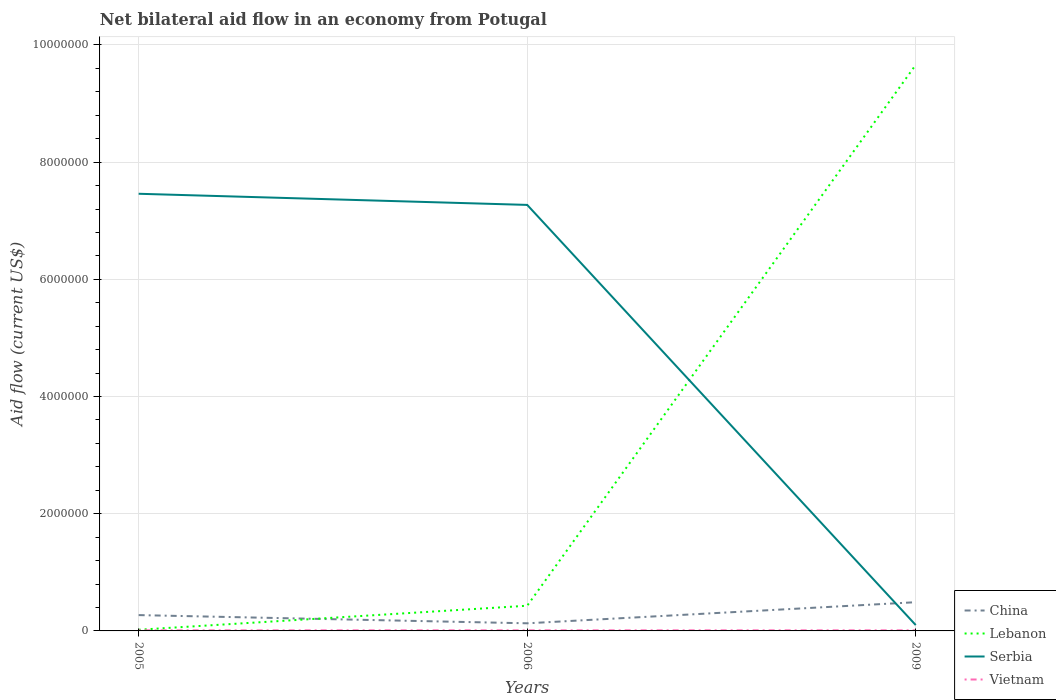How many different coloured lines are there?
Your answer should be very brief. 4. Does the line corresponding to Lebanon intersect with the line corresponding to Vietnam?
Make the answer very short. No. Is the number of lines equal to the number of legend labels?
Provide a succinct answer. Yes. In which year was the net bilateral aid flow in Serbia maximum?
Ensure brevity in your answer.  2009. What is the total net bilateral aid flow in Lebanon in the graph?
Keep it short and to the point. -9.64e+06. What is the difference between the highest and the second highest net bilateral aid flow in Serbia?
Provide a short and direct response. 7.36e+06. How many lines are there?
Your response must be concise. 4. What is the difference between two consecutive major ticks on the Y-axis?
Offer a terse response. 2.00e+06. Does the graph contain any zero values?
Give a very brief answer. No. How are the legend labels stacked?
Offer a very short reply. Vertical. What is the title of the graph?
Give a very brief answer. Net bilateral aid flow in an economy from Potugal. What is the label or title of the Y-axis?
Give a very brief answer. Aid flow (current US$). What is the Aid flow (current US$) of China in 2005?
Make the answer very short. 2.70e+05. What is the Aid flow (current US$) of Serbia in 2005?
Your answer should be very brief. 7.46e+06. What is the Aid flow (current US$) of China in 2006?
Your answer should be compact. 1.30e+05. What is the Aid flow (current US$) in Serbia in 2006?
Provide a short and direct response. 7.27e+06. What is the Aid flow (current US$) in Vietnam in 2006?
Provide a short and direct response. 10000. What is the Aid flow (current US$) in China in 2009?
Your answer should be compact. 4.90e+05. What is the Aid flow (current US$) of Lebanon in 2009?
Offer a terse response. 9.66e+06. What is the Aid flow (current US$) of Serbia in 2009?
Your response must be concise. 1.00e+05. Across all years, what is the maximum Aid flow (current US$) in Lebanon?
Give a very brief answer. 9.66e+06. Across all years, what is the maximum Aid flow (current US$) in Serbia?
Offer a terse response. 7.46e+06. Across all years, what is the minimum Aid flow (current US$) in China?
Make the answer very short. 1.30e+05. Across all years, what is the minimum Aid flow (current US$) in Lebanon?
Your answer should be very brief. 2.00e+04. Across all years, what is the minimum Aid flow (current US$) of Vietnam?
Give a very brief answer. 10000. What is the total Aid flow (current US$) of China in the graph?
Offer a terse response. 8.90e+05. What is the total Aid flow (current US$) of Lebanon in the graph?
Make the answer very short. 1.01e+07. What is the total Aid flow (current US$) in Serbia in the graph?
Offer a very short reply. 1.48e+07. What is the difference between the Aid flow (current US$) in Lebanon in 2005 and that in 2006?
Your answer should be very brief. -4.10e+05. What is the difference between the Aid flow (current US$) of China in 2005 and that in 2009?
Provide a succinct answer. -2.20e+05. What is the difference between the Aid flow (current US$) of Lebanon in 2005 and that in 2009?
Provide a succinct answer. -9.64e+06. What is the difference between the Aid flow (current US$) of Serbia in 2005 and that in 2009?
Make the answer very short. 7.36e+06. What is the difference between the Aid flow (current US$) of Vietnam in 2005 and that in 2009?
Give a very brief answer. 0. What is the difference between the Aid flow (current US$) in China in 2006 and that in 2009?
Provide a short and direct response. -3.60e+05. What is the difference between the Aid flow (current US$) of Lebanon in 2006 and that in 2009?
Offer a very short reply. -9.23e+06. What is the difference between the Aid flow (current US$) in Serbia in 2006 and that in 2009?
Offer a very short reply. 7.17e+06. What is the difference between the Aid flow (current US$) of China in 2005 and the Aid flow (current US$) of Serbia in 2006?
Your answer should be compact. -7.00e+06. What is the difference between the Aid flow (current US$) of Lebanon in 2005 and the Aid flow (current US$) of Serbia in 2006?
Your response must be concise. -7.25e+06. What is the difference between the Aid flow (current US$) of Serbia in 2005 and the Aid flow (current US$) of Vietnam in 2006?
Your response must be concise. 7.45e+06. What is the difference between the Aid flow (current US$) in China in 2005 and the Aid flow (current US$) in Lebanon in 2009?
Keep it short and to the point. -9.39e+06. What is the difference between the Aid flow (current US$) of China in 2005 and the Aid flow (current US$) of Serbia in 2009?
Offer a very short reply. 1.70e+05. What is the difference between the Aid flow (current US$) in China in 2005 and the Aid flow (current US$) in Vietnam in 2009?
Offer a very short reply. 2.60e+05. What is the difference between the Aid flow (current US$) in Lebanon in 2005 and the Aid flow (current US$) in Serbia in 2009?
Ensure brevity in your answer.  -8.00e+04. What is the difference between the Aid flow (current US$) in Serbia in 2005 and the Aid flow (current US$) in Vietnam in 2009?
Your response must be concise. 7.45e+06. What is the difference between the Aid flow (current US$) of China in 2006 and the Aid flow (current US$) of Lebanon in 2009?
Offer a very short reply. -9.53e+06. What is the difference between the Aid flow (current US$) in China in 2006 and the Aid flow (current US$) in Vietnam in 2009?
Offer a very short reply. 1.20e+05. What is the difference between the Aid flow (current US$) in Serbia in 2006 and the Aid flow (current US$) in Vietnam in 2009?
Offer a very short reply. 7.26e+06. What is the average Aid flow (current US$) in China per year?
Give a very brief answer. 2.97e+05. What is the average Aid flow (current US$) of Lebanon per year?
Give a very brief answer. 3.37e+06. What is the average Aid flow (current US$) in Serbia per year?
Offer a terse response. 4.94e+06. What is the average Aid flow (current US$) in Vietnam per year?
Offer a very short reply. 10000. In the year 2005, what is the difference between the Aid flow (current US$) of China and Aid flow (current US$) of Lebanon?
Provide a short and direct response. 2.50e+05. In the year 2005, what is the difference between the Aid flow (current US$) in China and Aid flow (current US$) in Serbia?
Your answer should be compact. -7.19e+06. In the year 2005, what is the difference between the Aid flow (current US$) in Lebanon and Aid flow (current US$) in Serbia?
Provide a short and direct response. -7.44e+06. In the year 2005, what is the difference between the Aid flow (current US$) of Lebanon and Aid flow (current US$) of Vietnam?
Keep it short and to the point. 10000. In the year 2005, what is the difference between the Aid flow (current US$) of Serbia and Aid flow (current US$) of Vietnam?
Offer a very short reply. 7.45e+06. In the year 2006, what is the difference between the Aid flow (current US$) in China and Aid flow (current US$) in Lebanon?
Your response must be concise. -3.00e+05. In the year 2006, what is the difference between the Aid flow (current US$) in China and Aid flow (current US$) in Serbia?
Provide a short and direct response. -7.14e+06. In the year 2006, what is the difference between the Aid flow (current US$) of China and Aid flow (current US$) of Vietnam?
Provide a short and direct response. 1.20e+05. In the year 2006, what is the difference between the Aid flow (current US$) of Lebanon and Aid flow (current US$) of Serbia?
Ensure brevity in your answer.  -6.84e+06. In the year 2006, what is the difference between the Aid flow (current US$) in Serbia and Aid flow (current US$) in Vietnam?
Offer a very short reply. 7.26e+06. In the year 2009, what is the difference between the Aid flow (current US$) of China and Aid flow (current US$) of Lebanon?
Your answer should be compact. -9.17e+06. In the year 2009, what is the difference between the Aid flow (current US$) in China and Aid flow (current US$) in Vietnam?
Your response must be concise. 4.80e+05. In the year 2009, what is the difference between the Aid flow (current US$) of Lebanon and Aid flow (current US$) of Serbia?
Your answer should be compact. 9.56e+06. In the year 2009, what is the difference between the Aid flow (current US$) of Lebanon and Aid flow (current US$) of Vietnam?
Ensure brevity in your answer.  9.65e+06. What is the ratio of the Aid flow (current US$) of China in 2005 to that in 2006?
Keep it short and to the point. 2.08. What is the ratio of the Aid flow (current US$) of Lebanon in 2005 to that in 2006?
Your response must be concise. 0.05. What is the ratio of the Aid flow (current US$) in Serbia in 2005 to that in 2006?
Make the answer very short. 1.03. What is the ratio of the Aid flow (current US$) of Vietnam in 2005 to that in 2006?
Your answer should be very brief. 1. What is the ratio of the Aid flow (current US$) of China in 2005 to that in 2009?
Offer a terse response. 0.55. What is the ratio of the Aid flow (current US$) in Lebanon in 2005 to that in 2009?
Make the answer very short. 0. What is the ratio of the Aid flow (current US$) of Serbia in 2005 to that in 2009?
Provide a succinct answer. 74.6. What is the ratio of the Aid flow (current US$) in Vietnam in 2005 to that in 2009?
Your answer should be compact. 1. What is the ratio of the Aid flow (current US$) of China in 2006 to that in 2009?
Provide a short and direct response. 0.27. What is the ratio of the Aid flow (current US$) in Lebanon in 2006 to that in 2009?
Ensure brevity in your answer.  0.04. What is the ratio of the Aid flow (current US$) in Serbia in 2006 to that in 2009?
Give a very brief answer. 72.7. What is the difference between the highest and the second highest Aid flow (current US$) of China?
Your answer should be very brief. 2.20e+05. What is the difference between the highest and the second highest Aid flow (current US$) in Lebanon?
Provide a succinct answer. 9.23e+06. What is the difference between the highest and the second highest Aid flow (current US$) in Serbia?
Offer a terse response. 1.90e+05. What is the difference between the highest and the second highest Aid flow (current US$) in Vietnam?
Provide a short and direct response. 0. What is the difference between the highest and the lowest Aid flow (current US$) of Lebanon?
Ensure brevity in your answer.  9.64e+06. What is the difference between the highest and the lowest Aid flow (current US$) in Serbia?
Your answer should be very brief. 7.36e+06. What is the difference between the highest and the lowest Aid flow (current US$) of Vietnam?
Make the answer very short. 0. 